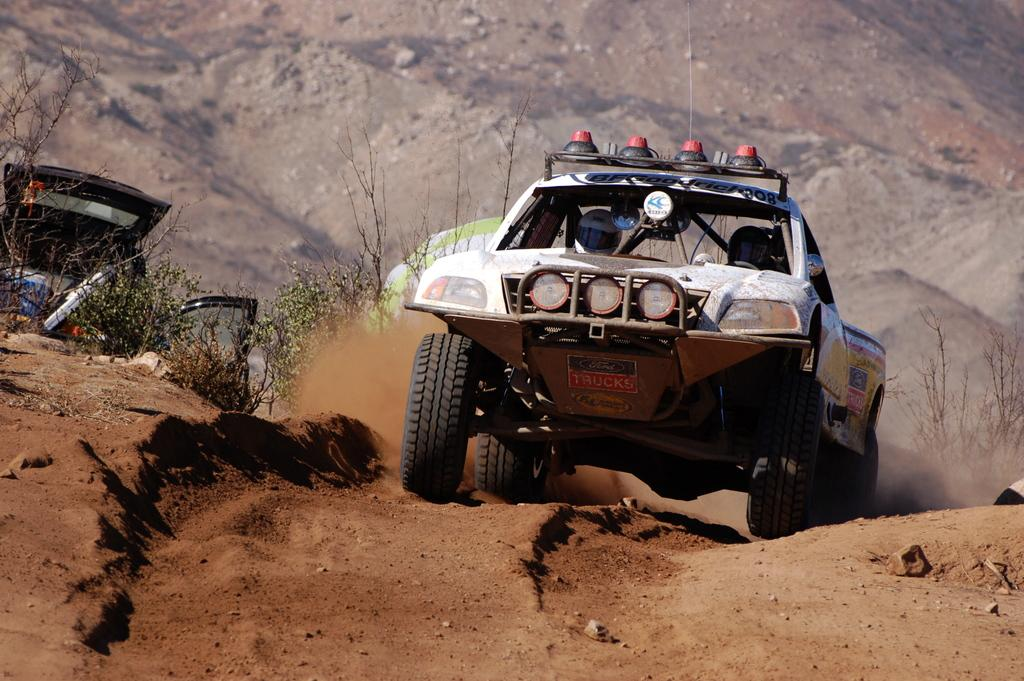What is the main subject of the image? There is a car in the image. What color is the car? The car is white. Is the car stationary or moving in the image? The car is moving in the image. What type of vegetation can be seen on the left side of the image? There are green plants on the left side of the image. Where is the picture of the head located in the image? There is no picture of a head present in the image. What type of tub is visible in the image? There is no tub present in the image. 